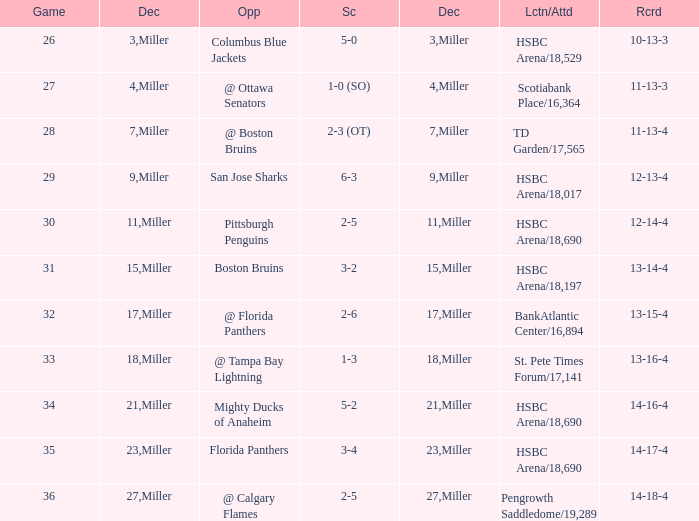Name the score for 29 game 6-3. 